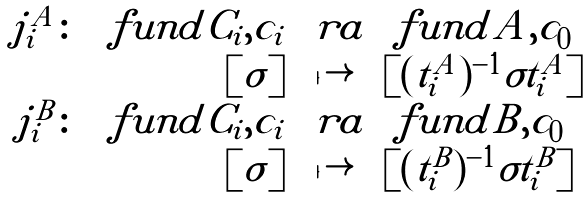<formula> <loc_0><loc_0><loc_500><loc_500>\begin{array} { r r c l } j _ { i } ^ { A } \colon & \ f u n d { C _ { i } , c _ { i } } & \ r a & \ f u n d { A , c _ { 0 } } \\ & [ \sigma ] & \mapsto & [ ( t _ { i } ^ { A } ) ^ { - 1 } \sigma t _ { i } ^ { A } ] \\ j _ { i } ^ { B } \colon & \ f u n d { C _ { i } , c _ { i } } & \ r a & \ f u n d { B , c _ { 0 } } \\ & [ \sigma ] & \mapsto & [ ( t _ { i } ^ { B } ) ^ { - 1 } \sigma t _ { i } ^ { B } ] \\ \end{array}</formula> 